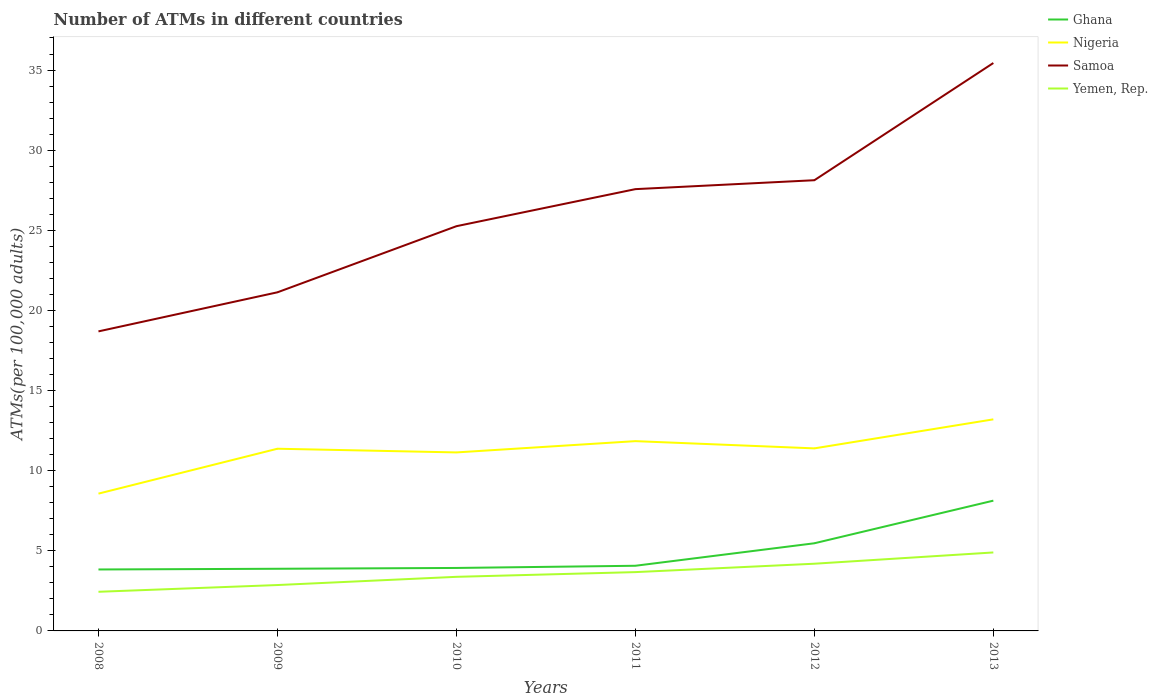Does the line corresponding to Yemen, Rep. intersect with the line corresponding to Nigeria?
Your answer should be very brief. No. Across all years, what is the maximum number of ATMs in Samoa?
Provide a short and direct response. 18.69. What is the total number of ATMs in Ghana in the graph?
Provide a succinct answer. -1.4. What is the difference between the highest and the second highest number of ATMs in Samoa?
Keep it short and to the point. 16.75. What is the difference between the highest and the lowest number of ATMs in Nigeria?
Your answer should be very brief. 4. How many lines are there?
Your response must be concise. 4. What is the difference between two consecutive major ticks on the Y-axis?
Make the answer very short. 5. Are the values on the major ticks of Y-axis written in scientific E-notation?
Make the answer very short. No. Does the graph contain grids?
Offer a terse response. No. Where does the legend appear in the graph?
Your answer should be very brief. Top right. How many legend labels are there?
Keep it short and to the point. 4. How are the legend labels stacked?
Your answer should be very brief. Vertical. What is the title of the graph?
Your response must be concise. Number of ATMs in different countries. Does "Slovak Republic" appear as one of the legend labels in the graph?
Offer a very short reply. No. What is the label or title of the Y-axis?
Your answer should be very brief. ATMs(per 100,0 adults). What is the ATMs(per 100,000 adults) of Ghana in 2008?
Keep it short and to the point. 3.84. What is the ATMs(per 100,000 adults) of Nigeria in 2008?
Your answer should be compact. 8.57. What is the ATMs(per 100,000 adults) of Samoa in 2008?
Your answer should be compact. 18.69. What is the ATMs(per 100,000 adults) of Yemen, Rep. in 2008?
Offer a terse response. 2.44. What is the ATMs(per 100,000 adults) of Ghana in 2009?
Provide a short and direct response. 3.88. What is the ATMs(per 100,000 adults) in Nigeria in 2009?
Your answer should be compact. 11.37. What is the ATMs(per 100,000 adults) of Samoa in 2009?
Offer a very short reply. 21.13. What is the ATMs(per 100,000 adults) of Yemen, Rep. in 2009?
Make the answer very short. 2.86. What is the ATMs(per 100,000 adults) in Ghana in 2010?
Give a very brief answer. 3.93. What is the ATMs(per 100,000 adults) of Nigeria in 2010?
Offer a terse response. 11.14. What is the ATMs(per 100,000 adults) of Samoa in 2010?
Provide a short and direct response. 25.26. What is the ATMs(per 100,000 adults) of Yemen, Rep. in 2010?
Provide a short and direct response. 3.38. What is the ATMs(per 100,000 adults) of Ghana in 2011?
Your response must be concise. 4.07. What is the ATMs(per 100,000 adults) of Nigeria in 2011?
Make the answer very short. 11.84. What is the ATMs(per 100,000 adults) of Samoa in 2011?
Keep it short and to the point. 27.57. What is the ATMs(per 100,000 adults) in Yemen, Rep. in 2011?
Provide a succinct answer. 3.67. What is the ATMs(per 100,000 adults) of Ghana in 2012?
Keep it short and to the point. 5.47. What is the ATMs(per 100,000 adults) of Nigeria in 2012?
Provide a succinct answer. 11.39. What is the ATMs(per 100,000 adults) in Samoa in 2012?
Provide a succinct answer. 28.12. What is the ATMs(per 100,000 adults) in Yemen, Rep. in 2012?
Your answer should be very brief. 4.19. What is the ATMs(per 100,000 adults) in Ghana in 2013?
Your answer should be very brief. 8.13. What is the ATMs(per 100,000 adults) in Nigeria in 2013?
Your answer should be very brief. 13.2. What is the ATMs(per 100,000 adults) in Samoa in 2013?
Offer a terse response. 35.44. What is the ATMs(per 100,000 adults) of Yemen, Rep. in 2013?
Make the answer very short. 4.9. Across all years, what is the maximum ATMs(per 100,000 adults) in Ghana?
Keep it short and to the point. 8.13. Across all years, what is the maximum ATMs(per 100,000 adults) in Nigeria?
Give a very brief answer. 13.2. Across all years, what is the maximum ATMs(per 100,000 adults) of Samoa?
Provide a short and direct response. 35.44. Across all years, what is the maximum ATMs(per 100,000 adults) of Yemen, Rep.?
Offer a terse response. 4.9. Across all years, what is the minimum ATMs(per 100,000 adults) in Ghana?
Offer a very short reply. 3.84. Across all years, what is the minimum ATMs(per 100,000 adults) of Nigeria?
Your response must be concise. 8.57. Across all years, what is the minimum ATMs(per 100,000 adults) of Samoa?
Your response must be concise. 18.69. Across all years, what is the minimum ATMs(per 100,000 adults) of Yemen, Rep.?
Your answer should be very brief. 2.44. What is the total ATMs(per 100,000 adults) in Ghana in the graph?
Provide a short and direct response. 29.31. What is the total ATMs(per 100,000 adults) of Nigeria in the graph?
Offer a very short reply. 67.51. What is the total ATMs(per 100,000 adults) in Samoa in the graph?
Make the answer very short. 156.21. What is the total ATMs(per 100,000 adults) of Yemen, Rep. in the graph?
Offer a very short reply. 21.44. What is the difference between the ATMs(per 100,000 adults) of Ghana in 2008 and that in 2009?
Offer a very short reply. -0.04. What is the difference between the ATMs(per 100,000 adults) in Nigeria in 2008 and that in 2009?
Keep it short and to the point. -2.8. What is the difference between the ATMs(per 100,000 adults) of Samoa in 2008 and that in 2009?
Give a very brief answer. -2.44. What is the difference between the ATMs(per 100,000 adults) of Yemen, Rep. in 2008 and that in 2009?
Your answer should be very brief. -0.42. What is the difference between the ATMs(per 100,000 adults) of Ghana in 2008 and that in 2010?
Your response must be concise. -0.09. What is the difference between the ATMs(per 100,000 adults) in Nigeria in 2008 and that in 2010?
Offer a terse response. -2.57. What is the difference between the ATMs(per 100,000 adults) in Samoa in 2008 and that in 2010?
Your answer should be compact. -6.56. What is the difference between the ATMs(per 100,000 adults) in Yemen, Rep. in 2008 and that in 2010?
Keep it short and to the point. -0.93. What is the difference between the ATMs(per 100,000 adults) of Ghana in 2008 and that in 2011?
Provide a short and direct response. -0.23. What is the difference between the ATMs(per 100,000 adults) of Nigeria in 2008 and that in 2011?
Provide a short and direct response. -3.28. What is the difference between the ATMs(per 100,000 adults) of Samoa in 2008 and that in 2011?
Offer a terse response. -8.88. What is the difference between the ATMs(per 100,000 adults) in Yemen, Rep. in 2008 and that in 2011?
Give a very brief answer. -1.23. What is the difference between the ATMs(per 100,000 adults) in Ghana in 2008 and that in 2012?
Offer a very short reply. -1.63. What is the difference between the ATMs(per 100,000 adults) of Nigeria in 2008 and that in 2012?
Offer a terse response. -2.82. What is the difference between the ATMs(per 100,000 adults) of Samoa in 2008 and that in 2012?
Your answer should be compact. -9.43. What is the difference between the ATMs(per 100,000 adults) in Yemen, Rep. in 2008 and that in 2012?
Your response must be concise. -1.75. What is the difference between the ATMs(per 100,000 adults) of Ghana in 2008 and that in 2013?
Ensure brevity in your answer.  -4.29. What is the difference between the ATMs(per 100,000 adults) of Nigeria in 2008 and that in 2013?
Provide a short and direct response. -4.64. What is the difference between the ATMs(per 100,000 adults) of Samoa in 2008 and that in 2013?
Make the answer very short. -16.75. What is the difference between the ATMs(per 100,000 adults) of Yemen, Rep. in 2008 and that in 2013?
Make the answer very short. -2.45. What is the difference between the ATMs(per 100,000 adults) of Ghana in 2009 and that in 2010?
Your answer should be very brief. -0.05. What is the difference between the ATMs(per 100,000 adults) in Nigeria in 2009 and that in 2010?
Your answer should be very brief. 0.23. What is the difference between the ATMs(per 100,000 adults) in Samoa in 2009 and that in 2010?
Your answer should be compact. -4.13. What is the difference between the ATMs(per 100,000 adults) of Yemen, Rep. in 2009 and that in 2010?
Provide a succinct answer. -0.51. What is the difference between the ATMs(per 100,000 adults) in Ghana in 2009 and that in 2011?
Provide a succinct answer. -0.19. What is the difference between the ATMs(per 100,000 adults) in Nigeria in 2009 and that in 2011?
Your answer should be very brief. -0.47. What is the difference between the ATMs(per 100,000 adults) of Samoa in 2009 and that in 2011?
Your answer should be very brief. -6.44. What is the difference between the ATMs(per 100,000 adults) in Yemen, Rep. in 2009 and that in 2011?
Your answer should be compact. -0.81. What is the difference between the ATMs(per 100,000 adults) of Ghana in 2009 and that in 2012?
Offer a very short reply. -1.59. What is the difference between the ATMs(per 100,000 adults) in Nigeria in 2009 and that in 2012?
Provide a short and direct response. -0.02. What is the difference between the ATMs(per 100,000 adults) of Samoa in 2009 and that in 2012?
Provide a succinct answer. -6.99. What is the difference between the ATMs(per 100,000 adults) of Yemen, Rep. in 2009 and that in 2012?
Provide a succinct answer. -1.33. What is the difference between the ATMs(per 100,000 adults) of Ghana in 2009 and that in 2013?
Provide a succinct answer. -4.25. What is the difference between the ATMs(per 100,000 adults) of Nigeria in 2009 and that in 2013?
Your response must be concise. -1.83. What is the difference between the ATMs(per 100,000 adults) of Samoa in 2009 and that in 2013?
Ensure brevity in your answer.  -14.31. What is the difference between the ATMs(per 100,000 adults) of Yemen, Rep. in 2009 and that in 2013?
Your answer should be compact. -2.03. What is the difference between the ATMs(per 100,000 adults) in Ghana in 2010 and that in 2011?
Provide a short and direct response. -0.14. What is the difference between the ATMs(per 100,000 adults) of Nigeria in 2010 and that in 2011?
Your response must be concise. -0.7. What is the difference between the ATMs(per 100,000 adults) in Samoa in 2010 and that in 2011?
Offer a terse response. -2.31. What is the difference between the ATMs(per 100,000 adults) in Yemen, Rep. in 2010 and that in 2011?
Provide a succinct answer. -0.29. What is the difference between the ATMs(per 100,000 adults) of Ghana in 2010 and that in 2012?
Your response must be concise. -1.54. What is the difference between the ATMs(per 100,000 adults) of Nigeria in 2010 and that in 2012?
Make the answer very short. -0.25. What is the difference between the ATMs(per 100,000 adults) of Samoa in 2010 and that in 2012?
Keep it short and to the point. -2.87. What is the difference between the ATMs(per 100,000 adults) of Yemen, Rep. in 2010 and that in 2012?
Ensure brevity in your answer.  -0.82. What is the difference between the ATMs(per 100,000 adults) of Ghana in 2010 and that in 2013?
Keep it short and to the point. -4.2. What is the difference between the ATMs(per 100,000 adults) of Nigeria in 2010 and that in 2013?
Give a very brief answer. -2.06. What is the difference between the ATMs(per 100,000 adults) of Samoa in 2010 and that in 2013?
Keep it short and to the point. -10.18. What is the difference between the ATMs(per 100,000 adults) in Yemen, Rep. in 2010 and that in 2013?
Offer a terse response. -1.52. What is the difference between the ATMs(per 100,000 adults) of Ghana in 2011 and that in 2012?
Offer a terse response. -1.4. What is the difference between the ATMs(per 100,000 adults) in Nigeria in 2011 and that in 2012?
Offer a terse response. 0.45. What is the difference between the ATMs(per 100,000 adults) in Samoa in 2011 and that in 2012?
Provide a succinct answer. -0.56. What is the difference between the ATMs(per 100,000 adults) of Yemen, Rep. in 2011 and that in 2012?
Provide a short and direct response. -0.52. What is the difference between the ATMs(per 100,000 adults) in Ghana in 2011 and that in 2013?
Offer a very short reply. -4.06. What is the difference between the ATMs(per 100,000 adults) in Nigeria in 2011 and that in 2013?
Give a very brief answer. -1.36. What is the difference between the ATMs(per 100,000 adults) in Samoa in 2011 and that in 2013?
Your response must be concise. -7.87. What is the difference between the ATMs(per 100,000 adults) in Yemen, Rep. in 2011 and that in 2013?
Keep it short and to the point. -1.23. What is the difference between the ATMs(per 100,000 adults) in Ghana in 2012 and that in 2013?
Ensure brevity in your answer.  -2.66. What is the difference between the ATMs(per 100,000 adults) in Nigeria in 2012 and that in 2013?
Your answer should be compact. -1.81. What is the difference between the ATMs(per 100,000 adults) of Samoa in 2012 and that in 2013?
Give a very brief answer. -7.31. What is the difference between the ATMs(per 100,000 adults) of Yemen, Rep. in 2012 and that in 2013?
Your response must be concise. -0.7. What is the difference between the ATMs(per 100,000 adults) in Ghana in 2008 and the ATMs(per 100,000 adults) in Nigeria in 2009?
Keep it short and to the point. -7.53. What is the difference between the ATMs(per 100,000 adults) of Ghana in 2008 and the ATMs(per 100,000 adults) of Samoa in 2009?
Make the answer very short. -17.3. What is the difference between the ATMs(per 100,000 adults) of Ghana in 2008 and the ATMs(per 100,000 adults) of Yemen, Rep. in 2009?
Offer a very short reply. 0.97. What is the difference between the ATMs(per 100,000 adults) of Nigeria in 2008 and the ATMs(per 100,000 adults) of Samoa in 2009?
Offer a terse response. -12.56. What is the difference between the ATMs(per 100,000 adults) in Nigeria in 2008 and the ATMs(per 100,000 adults) in Yemen, Rep. in 2009?
Keep it short and to the point. 5.7. What is the difference between the ATMs(per 100,000 adults) in Samoa in 2008 and the ATMs(per 100,000 adults) in Yemen, Rep. in 2009?
Your response must be concise. 15.83. What is the difference between the ATMs(per 100,000 adults) of Ghana in 2008 and the ATMs(per 100,000 adults) of Nigeria in 2010?
Your response must be concise. -7.3. What is the difference between the ATMs(per 100,000 adults) of Ghana in 2008 and the ATMs(per 100,000 adults) of Samoa in 2010?
Your response must be concise. -21.42. What is the difference between the ATMs(per 100,000 adults) in Ghana in 2008 and the ATMs(per 100,000 adults) in Yemen, Rep. in 2010?
Provide a succinct answer. 0.46. What is the difference between the ATMs(per 100,000 adults) of Nigeria in 2008 and the ATMs(per 100,000 adults) of Samoa in 2010?
Your answer should be compact. -16.69. What is the difference between the ATMs(per 100,000 adults) in Nigeria in 2008 and the ATMs(per 100,000 adults) in Yemen, Rep. in 2010?
Give a very brief answer. 5.19. What is the difference between the ATMs(per 100,000 adults) in Samoa in 2008 and the ATMs(per 100,000 adults) in Yemen, Rep. in 2010?
Offer a terse response. 15.32. What is the difference between the ATMs(per 100,000 adults) in Ghana in 2008 and the ATMs(per 100,000 adults) in Nigeria in 2011?
Your response must be concise. -8.01. What is the difference between the ATMs(per 100,000 adults) of Ghana in 2008 and the ATMs(per 100,000 adults) of Samoa in 2011?
Give a very brief answer. -23.73. What is the difference between the ATMs(per 100,000 adults) of Ghana in 2008 and the ATMs(per 100,000 adults) of Yemen, Rep. in 2011?
Your response must be concise. 0.16. What is the difference between the ATMs(per 100,000 adults) in Nigeria in 2008 and the ATMs(per 100,000 adults) in Samoa in 2011?
Provide a succinct answer. -19. What is the difference between the ATMs(per 100,000 adults) in Nigeria in 2008 and the ATMs(per 100,000 adults) in Yemen, Rep. in 2011?
Your answer should be very brief. 4.9. What is the difference between the ATMs(per 100,000 adults) in Samoa in 2008 and the ATMs(per 100,000 adults) in Yemen, Rep. in 2011?
Your response must be concise. 15.02. What is the difference between the ATMs(per 100,000 adults) of Ghana in 2008 and the ATMs(per 100,000 adults) of Nigeria in 2012?
Ensure brevity in your answer.  -7.56. What is the difference between the ATMs(per 100,000 adults) in Ghana in 2008 and the ATMs(per 100,000 adults) in Samoa in 2012?
Provide a succinct answer. -24.29. What is the difference between the ATMs(per 100,000 adults) of Ghana in 2008 and the ATMs(per 100,000 adults) of Yemen, Rep. in 2012?
Ensure brevity in your answer.  -0.36. What is the difference between the ATMs(per 100,000 adults) in Nigeria in 2008 and the ATMs(per 100,000 adults) in Samoa in 2012?
Ensure brevity in your answer.  -19.56. What is the difference between the ATMs(per 100,000 adults) in Nigeria in 2008 and the ATMs(per 100,000 adults) in Yemen, Rep. in 2012?
Give a very brief answer. 4.37. What is the difference between the ATMs(per 100,000 adults) in Samoa in 2008 and the ATMs(per 100,000 adults) in Yemen, Rep. in 2012?
Keep it short and to the point. 14.5. What is the difference between the ATMs(per 100,000 adults) of Ghana in 2008 and the ATMs(per 100,000 adults) of Nigeria in 2013?
Offer a terse response. -9.37. What is the difference between the ATMs(per 100,000 adults) in Ghana in 2008 and the ATMs(per 100,000 adults) in Samoa in 2013?
Ensure brevity in your answer.  -31.6. What is the difference between the ATMs(per 100,000 adults) in Ghana in 2008 and the ATMs(per 100,000 adults) in Yemen, Rep. in 2013?
Offer a very short reply. -1.06. What is the difference between the ATMs(per 100,000 adults) of Nigeria in 2008 and the ATMs(per 100,000 adults) of Samoa in 2013?
Your response must be concise. -26.87. What is the difference between the ATMs(per 100,000 adults) in Nigeria in 2008 and the ATMs(per 100,000 adults) in Yemen, Rep. in 2013?
Provide a short and direct response. 3.67. What is the difference between the ATMs(per 100,000 adults) of Samoa in 2008 and the ATMs(per 100,000 adults) of Yemen, Rep. in 2013?
Your response must be concise. 13.79. What is the difference between the ATMs(per 100,000 adults) of Ghana in 2009 and the ATMs(per 100,000 adults) of Nigeria in 2010?
Provide a short and direct response. -7.26. What is the difference between the ATMs(per 100,000 adults) in Ghana in 2009 and the ATMs(per 100,000 adults) in Samoa in 2010?
Offer a very short reply. -21.38. What is the difference between the ATMs(per 100,000 adults) of Ghana in 2009 and the ATMs(per 100,000 adults) of Yemen, Rep. in 2010?
Offer a terse response. 0.5. What is the difference between the ATMs(per 100,000 adults) of Nigeria in 2009 and the ATMs(per 100,000 adults) of Samoa in 2010?
Your answer should be compact. -13.89. What is the difference between the ATMs(per 100,000 adults) in Nigeria in 2009 and the ATMs(per 100,000 adults) in Yemen, Rep. in 2010?
Ensure brevity in your answer.  7.99. What is the difference between the ATMs(per 100,000 adults) of Samoa in 2009 and the ATMs(per 100,000 adults) of Yemen, Rep. in 2010?
Make the answer very short. 17.75. What is the difference between the ATMs(per 100,000 adults) in Ghana in 2009 and the ATMs(per 100,000 adults) in Nigeria in 2011?
Your answer should be very brief. -7.96. What is the difference between the ATMs(per 100,000 adults) of Ghana in 2009 and the ATMs(per 100,000 adults) of Samoa in 2011?
Keep it short and to the point. -23.69. What is the difference between the ATMs(per 100,000 adults) of Ghana in 2009 and the ATMs(per 100,000 adults) of Yemen, Rep. in 2011?
Offer a terse response. 0.21. What is the difference between the ATMs(per 100,000 adults) in Nigeria in 2009 and the ATMs(per 100,000 adults) in Samoa in 2011?
Your answer should be compact. -16.2. What is the difference between the ATMs(per 100,000 adults) in Nigeria in 2009 and the ATMs(per 100,000 adults) in Yemen, Rep. in 2011?
Provide a short and direct response. 7.7. What is the difference between the ATMs(per 100,000 adults) in Samoa in 2009 and the ATMs(per 100,000 adults) in Yemen, Rep. in 2011?
Give a very brief answer. 17.46. What is the difference between the ATMs(per 100,000 adults) in Ghana in 2009 and the ATMs(per 100,000 adults) in Nigeria in 2012?
Keep it short and to the point. -7.51. What is the difference between the ATMs(per 100,000 adults) in Ghana in 2009 and the ATMs(per 100,000 adults) in Samoa in 2012?
Keep it short and to the point. -24.25. What is the difference between the ATMs(per 100,000 adults) of Ghana in 2009 and the ATMs(per 100,000 adults) of Yemen, Rep. in 2012?
Keep it short and to the point. -0.31. What is the difference between the ATMs(per 100,000 adults) of Nigeria in 2009 and the ATMs(per 100,000 adults) of Samoa in 2012?
Offer a very short reply. -16.76. What is the difference between the ATMs(per 100,000 adults) of Nigeria in 2009 and the ATMs(per 100,000 adults) of Yemen, Rep. in 2012?
Ensure brevity in your answer.  7.18. What is the difference between the ATMs(per 100,000 adults) in Samoa in 2009 and the ATMs(per 100,000 adults) in Yemen, Rep. in 2012?
Provide a short and direct response. 16.94. What is the difference between the ATMs(per 100,000 adults) in Ghana in 2009 and the ATMs(per 100,000 adults) in Nigeria in 2013?
Provide a short and direct response. -9.32. What is the difference between the ATMs(per 100,000 adults) of Ghana in 2009 and the ATMs(per 100,000 adults) of Samoa in 2013?
Your answer should be compact. -31.56. What is the difference between the ATMs(per 100,000 adults) in Ghana in 2009 and the ATMs(per 100,000 adults) in Yemen, Rep. in 2013?
Provide a short and direct response. -1.02. What is the difference between the ATMs(per 100,000 adults) of Nigeria in 2009 and the ATMs(per 100,000 adults) of Samoa in 2013?
Give a very brief answer. -24.07. What is the difference between the ATMs(per 100,000 adults) in Nigeria in 2009 and the ATMs(per 100,000 adults) in Yemen, Rep. in 2013?
Provide a succinct answer. 6.47. What is the difference between the ATMs(per 100,000 adults) of Samoa in 2009 and the ATMs(per 100,000 adults) of Yemen, Rep. in 2013?
Make the answer very short. 16.23. What is the difference between the ATMs(per 100,000 adults) of Ghana in 2010 and the ATMs(per 100,000 adults) of Nigeria in 2011?
Your response must be concise. -7.91. What is the difference between the ATMs(per 100,000 adults) of Ghana in 2010 and the ATMs(per 100,000 adults) of Samoa in 2011?
Provide a short and direct response. -23.64. What is the difference between the ATMs(per 100,000 adults) of Ghana in 2010 and the ATMs(per 100,000 adults) of Yemen, Rep. in 2011?
Make the answer very short. 0.26. What is the difference between the ATMs(per 100,000 adults) in Nigeria in 2010 and the ATMs(per 100,000 adults) in Samoa in 2011?
Make the answer very short. -16.43. What is the difference between the ATMs(per 100,000 adults) of Nigeria in 2010 and the ATMs(per 100,000 adults) of Yemen, Rep. in 2011?
Make the answer very short. 7.47. What is the difference between the ATMs(per 100,000 adults) of Samoa in 2010 and the ATMs(per 100,000 adults) of Yemen, Rep. in 2011?
Make the answer very short. 21.59. What is the difference between the ATMs(per 100,000 adults) in Ghana in 2010 and the ATMs(per 100,000 adults) in Nigeria in 2012?
Give a very brief answer. -7.46. What is the difference between the ATMs(per 100,000 adults) in Ghana in 2010 and the ATMs(per 100,000 adults) in Samoa in 2012?
Offer a very short reply. -24.19. What is the difference between the ATMs(per 100,000 adults) in Ghana in 2010 and the ATMs(per 100,000 adults) in Yemen, Rep. in 2012?
Make the answer very short. -0.26. What is the difference between the ATMs(per 100,000 adults) in Nigeria in 2010 and the ATMs(per 100,000 adults) in Samoa in 2012?
Provide a short and direct response. -16.99. What is the difference between the ATMs(per 100,000 adults) of Nigeria in 2010 and the ATMs(per 100,000 adults) of Yemen, Rep. in 2012?
Keep it short and to the point. 6.95. What is the difference between the ATMs(per 100,000 adults) of Samoa in 2010 and the ATMs(per 100,000 adults) of Yemen, Rep. in 2012?
Offer a terse response. 21.06. What is the difference between the ATMs(per 100,000 adults) of Ghana in 2010 and the ATMs(per 100,000 adults) of Nigeria in 2013?
Provide a succinct answer. -9.27. What is the difference between the ATMs(per 100,000 adults) in Ghana in 2010 and the ATMs(per 100,000 adults) in Samoa in 2013?
Give a very brief answer. -31.51. What is the difference between the ATMs(per 100,000 adults) in Ghana in 2010 and the ATMs(per 100,000 adults) in Yemen, Rep. in 2013?
Provide a succinct answer. -0.97. What is the difference between the ATMs(per 100,000 adults) in Nigeria in 2010 and the ATMs(per 100,000 adults) in Samoa in 2013?
Offer a terse response. -24.3. What is the difference between the ATMs(per 100,000 adults) in Nigeria in 2010 and the ATMs(per 100,000 adults) in Yemen, Rep. in 2013?
Your answer should be compact. 6.24. What is the difference between the ATMs(per 100,000 adults) of Samoa in 2010 and the ATMs(per 100,000 adults) of Yemen, Rep. in 2013?
Offer a terse response. 20.36. What is the difference between the ATMs(per 100,000 adults) in Ghana in 2011 and the ATMs(per 100,000 adults) in Nigeria in 2012?
Provide a succinct answer. -7.32. What is the difference between the ATMs(per 100,000 adults) of Ghana in 2011 and the ATMs(per 100,000 adults) of Samoa in 2012?
Your answer should be very brief. -24.06. What is the difference between the ATMs(per 100,000 adults) in Ghana in 2011 and the ATMs(per 100,000 adults) in Yemen, Rep. in 2012?
Your response must be concise. -0.13. What is the difference between the ATMs(per 100,000 adults) in Nigeria in 2011 and the ATMs(per 100,000 adults) in Samoa in 2012?
Offer a very short reply. -16.28. What is the difference between the ATMs(per 100,000 adults) of Nigeria in 2011 and the ATMs(per 100,000 adults) of Yemen, Rep. in 2012?
Keep it short and to the point. 7.65. What is the difference between the ATMs(per 100,000 adults) of Samoa in 2011 and the ATMs(per 100,000 adults) of Yemen, Rep. in 2012?
Make the answer very short. 23.37. What is the difference between the ATMs(per 100,000 adults) of Ghana in 2011 and the ATMs(per 100,000 adults) of Nigeria in 2013?
Provide a succinct answer. -9.14. What is the difference between the ATMs(per 100,000 adults) in Ghana in 2011 and the ATMs(per 100,000 adults) in Samoa in 2013?
Your answer should be compact. -31.37. What is the difference between the ATMs(per 100,000 adults) in Ghana in 2011 and the ATMs(per 100,000 adults) in Yemen, Rep. in 2013?
Your response must be concise. -0.83. What is the difference between the ATMs(per 100,000 adults) in Nigeria in 2011 and the ATMs(per 100,000 adults) in Samoa in 2013?
Your answer should be compact. -23.6. What is the difference between the ATMs(per 100,000 adults) in Nigeria in 2011 and the ATMs(per 100,000 adults) in Yemen, Rep. in 2013?
Make the answer very short. 6.95. What is the difference between the ATMs(per 100,000 adults) in Samoa in 2011 and the ATMs(per 100,000 adults) in Yemen, Rep. in 2013?
Your answer should be very brief. 22.67. What is the difference between the ATMs(per 100,000 adults) of Ghana in 2012 and the ATMs(per 100,000 adults) of Nigeria in 2013?
Your response must be concise. -7.73. What is the difference between the ATMs(per 100,000 adults) in Ghana in 2012 and the ATMs(per 100,000 adults) in Samoa in 2013?
Offer a very short reply. -29.97. What is the difference between the ATMs(per 100,000 adults) of Ghana in 2012 and the ATMs(per 100,000 adults) of Yemen, Rep. in 2013?
Offer a terse response. 0.57. What is the difference between the ATMs(per 100,000 adults) of Nigeria in 2012 and the ATMs(per 100,000 adults) of Samoa in 2013?
Your answer should be compact. -24.05. What is the difference between the ATMs(per 100,000 adults) of Nigeria in 2012 and the ATMs(per 100,000 adults) of Yemen, Rep. in 2013?
Your answer should be very brief. 6.49. What is the difference between the ATMs(per 100,000 adults) of Samoa in 2012 and the ATMs(per 100,000 adults) of Yemen, Rep. in 2013?
Provide a succinct answer. 23.23. What is the average ATMs(per 100,000 adults) in Ghana per year?
Ensure brevity in your answer.  4.88. What is the average ATMs(per 100,000 adults) of Nigeria per year?
Ensure brevity in your answer.  11.25. What is the average ATMs(per 100,000 adults) in Samoa per year?
Give a very brief answer. 26.03. What is the average ATMs(per 100,000 adults) of Yemen, Rep. per year?
Offer a very short reply. 3.57. In the year 2008, what is the difference between the ATMs(per 100,000 adults) of Ghana and ATMs(per 100,000 adults) of Nigeria?
Your answer should be compact. -4.73. In the year 2008, what is the difference between the ATMs(per 100,000 adults) in Ghana and ATMs(per 100,000 adults) in Samoa?
Your response must be concise. -14.86. In the year 2008, what is the difference between the ATMs(per 100,000 adults) in Ghana and ATMs(per 100,000 adults) in Yemen, Rep.?
Your response must be concise. 1.39. In the year 2008, what is the difference between the ATMs(per 100,000 adults) of Nigeria and ATMs(per 100,000 adults) of Samoa?
Give a very brief answer. -10.12. In the year 2008, what is the difference between the ATMs(per 100,000 adults) of Nigeria and ATMs(per 100,000 adults) of Yemen, Rep.?
Provide a succinct answer. 6.12. In the year 2008, what is the difference between the ATMs(per 100,000 adults) in Samoa and ATMs(per 100,000 adults) in Yemen, Rep.?
Make the answer very short. 16.25. In the year 2009, what is the difference between the ATMs(per 100,000 adults) of Ghana and ATMs(per 100,000 adults) of Nigeria?
Ensure brevity in your answer.  -7.49. In the year 2009, what is the difference between the ATMs(per 100,000 adults) of Ghana and ATMs(per 100,000 adults) of Samoa?
Provide a succinct answer. -17.25. In the year 2009, what is the difference between the ATMs(per 100,000 adults) in Ghana and ATMs(per 100,000 adults) in Yemen, Rep.?
Your answer should be compact. 1.02. In the year 2009, what is the difference between the ATMs(per 100,000 adults) of Nigeria and ATMs(per 100,000 adults) of Samoa?
Offer a very short reply. -9.76. In the year 2009, what is the difference between the ATMs(per 100,000 adults) in Nigeria and ATMs(per 100,000 adults) in Yemen, Rep.?
Offer a very short reply. 8.51. In the year 2009, what is the difference between the ATMs(per 100,000 adults) of Samoa and ATMs(per 100,000 adults) of Yemen, Rep.?
Provide a succinct answer. 18.27. In the year 2010, what is the difference between the ATMs(per 100,000 adults) of Ghana and ATMs(per 100,000 adults) of Nigeria?
Your response must be concise. -7.21. In the year 2010, what is the difference between the ATMs(per 100,000 adults) of Ghana and ATMs(per 100,000 adults) of Samoa?
Provide a short and direct response. -21.33. In the year 2010, what is the difference between the ATMs(per 100,000 adults) in Ghana and ATMs(per 100,000 adults) in Yemen, Rep.?
Your answer should be very brief. 0.55. In the year 2010, what is the difference between the ATMs(per 100,000 adults) of Nigeria and ATMs(per 100,000 adults) of Samoa?
Provide a succinct answer. -14.12. In the year 2010, what is the difference between the ATMs(per 100,000 adults) of Nigeria and ATMs(per 100,000 adults) of Yemen, Rep.?
Provide a short and direct response. 7.76. In the year 2010, what is the difference between the ATMs(per 100,000 adults) in Samoa and ATMs(per 100,000 adults) in Yemen, Rep.?
Your answer should be very brief. 21.88. In the year 2011, what is the difference between the ATMs(per 100,000 adults) in Ghana and ATMs(per 100,000 adults) in Nigeria?
Ensure brevity in your answer.  -7.78. In the year 2011, what is the difference between the ATMs(per 100,000 adults) of Ghana and ATMs(per 100,000 adults) of Samoa?
Provide a short and direct response. -23.5. In the year 2011, what is the difference between the ATMs(per 100,000 adults) in Ghana and ATMs(per 100,000 adults) in Yemen, Rep.?
Your answer should be very brief. 0.4. In the year 2011, what is the difference between the ATMs(per 100,000 adults) in Nigeria and ATMs(per 100,000 adults) in Samoa?
Your answer should be very brief. -15.73. In the year 2011, what is the difference between the ATMs(per 100,000 adults) of Nigeria and ATMs(per 100,000 adults) of Yemen, Rep.?
Keep it short and to the point. 8.17. In the year 2011, what is the difference between the ATMs(per 100,000 adults) of Samoa and ATMs(per 100,000 adults) of Yemen, Rep.?
Provide a succinct answer. 23.9. In the year 2012, what is the difference between the ATMs(per 100,000 adults) in Ghana and ATMs(per 100,000 adults) in Nigeria?
Provide a short and direct response. -5.92. In the year 2012, what is the difference between the ATMs(per 100,000 adults) of Ghana and ATMs(per 100,000 adults) of Samoa?
Keep it short and to the point. -22.65. In the year 2012, what is the difference between the ATMs(per 100,000 adults) of Ghana and ATMs(per 100,000 adults) of Yemen, Rep.?
Your response must be concise. 1.28. In the year 2012, what is the difference between the ATMs(per 100,000 adults) in Nigeria and ATMs(per 100,000 adults) in Samoa?
Provide a succinct answer. -16.73. In the year 2012, what is the difference between the ATMs(per 100,000 adults) in Nigeria and ATMs(per 100,000 adults) in Yemen, Rep.?
Your response must be concise. 7.2. In the year 2012, what is the difference between the ATMs(per 100,000 adults) of Samoa and ATMs(per 100,000 adults) of Yemen, Rep.?
Provide a succinct answer. 23.93. In the year 2013, what is the difference between the ATMs(per 100,000 adults) in Ghana and ATMs(per 100,000 adults) in Nigeria?
Ensure brevity in your answer.  -5.07. In the year 2013, what is the difference between the ATMs(per 100,000 adults) of Ghana and ATMs(per 100,000 adults) of Samoa?
Offer a terse response. -27.31. In the year 2013, what is the difference between the ATMs(per 100,000 adults) of Ghana and ATMs(per 100,000 adults) of Yemen, Rep.?
Keep it short and to the point. 3.23. In the year 2013, what is the difference between the ATMs(per 100,000 adults) of Nigeria and ATMs(per 100,000 adults) of Samoa?
Your response must be concise. -22.24. In the year 2013, what is the difference between the ATMs(per 100,000 adults) of Nigeria and ATMs(per 100,000 adults) of Yemen, Rep.?
Offer a very short reply. 8.31. In the year 2013, what is the difference between the ATMs(per 100,000 adults) in Samoa and ATMs(per 100,000 adults) in Yemen, Rep.?
Provide a succinct answer. 30.54. What is the ratio of the ATMs(per 100,000 adults) of Ghana in 2008 to that in 2009?
Give a very brief answer. 0.99. What is the ratio of the ATMs(per 100,000 adults) in Nigeria in 2008 to that in 2009?
Your answer should be compact. 0.75. What is the ratio of the ATMs(per 100,000 adults) of Samoa in 2008 to that in 2009?
Offer a terse response. 0.88. What is the ratio of the ATMs(per 100,000 adults) of Yemen, Rep. in 2008 to that in 2009?
Your answer should be compact. 0.85. What is the ratio of the ATMs(per 100,000 adults) of Nigeria in 2008 to that in 2010?
Make the answer very short. 0.77. What is the ratio of the ATMs(per 100,000 adults) of Samoa in 2008 to that in 2010?
Your answer should be very brief. 0.74. What is the ratio of the ATMs(per 100,000 adults) in Yemen, Rep. in 2008 to that in 2010?
Offer a terse response. 0.72. What is the ratio of the ATMs(per 100,000 adults) in Ghana in 2008 to that in 2011?
Ensure brevity in your answer.  0.94. What is the ratio of the ATMs(per 100,000 adults) of Nigeria in 2008 to that in 2011?
Provide a short and direct response. 0.72. What is the ratio of the ATMs(per 100,000 adults) of Samoa in 2008 to that in 2011?
Your answer should be compact. 0.68. What is the ratio of the ATMs(per 100,000 adults) of Yemen, Rep. in 2008 to that in 2011?
Your response must be concise. 0.67. What is the ratio of the ATMs(per 100,000 adults) of Ghana in 2008 to that in 2012?
Offer a terse response. 0.7. What is the ratio of the ATMs(per 100,000 adults) of Nigeria in 2008 to that in 2012?
Your answer should be very brief. 0.75. What is the ratio of the ATMs(per 100,000 adults) in Samoa in 2008 to that in 2012?
Make the answer very short. 0.66. What is the ratio of the ATMs(per 100,000 adults) of Yemen, Rep. in 2008 to that in 2012?
Make the answer very short. 0.58. What is the ratio of the ATMs(per 100,000 adults) of Ghana in 2008 to that in 2013?
Offer a terse response. 0.47. What is the ratio of the ATMs(per 100,000 adults) in Nigeria in 2008 to that in 2013?
Your answer should be very brief. 0.65. What is the ratio of the ATMs(per 100,000 adults) in Samoa in 2008 to that in 2013?
Give a very brief answer. 0.53. What is the ratio of the ATMs(per 100,000 adults) of Yemen, Rep. in 2008 to that in 2013?
Keep it short and to the point. 0.5. What is the ratio of the ATMs(per 100,000 adults) in Ghana in 2009 to that in 2010?
Ensure brevity in your answer.  0.99. What is the ratio of the ATMs(per 100,000 adults) of Nigeria in 2009 to that in 2010?
Provide a succinct answer. 1.02. What is the ratio of the ATMs(per 100,000 adults) in Samoa in 2009 to that in 2010?
Provide a short and direct response. 0.84. What is the ratio of the ATMs(per 100,000 adults) of Yemen, Rep. in 2009 to that in 2010?
Give a very brief answer. 0.85. What is the ratio of the ATMs(per 100,000 adults) of Ghana in 2009 to that in 2011?
Keep it short and to the point. 0.95. What is the ratio of the ATMs(per 100,000 adults) in Samoa in 2009 to that in 2011?
Ensure brevity in your answer.  0.77. What is the ratio of the ATMs(per 100,000 adults) in Yemen, Rep. in 2009 to that in 2011?
Provide a succinct answer. 0.78. What is the ratio of the ATMs(per 100,000 adults) of Ghana in 2009 to that in 2012?
Provide a short and direct response. 0.71. What is the ratio of the ATMs(per 100,000 adults) in Nigeria in 2009 to that in 2012?
Provide a succinct answer. 1. What is the ratio of the ATMs(per 100,000 adults) of Samoa in 2009 to that in 2012?
Your answer should be very brief. 0.75. What is the ratio of the ATMs(per 100,000 adults) of Yemen, Rep. in 2009 to that in 2012?
Your answer should be compact. 0.68. What is the ratio of the ATMs(per 100,000 adults) of Ghana in 2009 to that in 2013?
Give a very brief answer. 0.48. What is the ratio of the ATMs(per 100,000 adults) of Nigeria in 2009 to that in 2013?
Offer a terse response. 0.86. What is the ratio of the ATMs(per 100,000 adults) in Samoa in 2009 to that in 2013?
Make the answer very short. 0.6. What is the ratio of the ATMs(per 100,000 adults) in Yemen, Rep. in 2009 to that in 2013?
Your answer should be very brief. 0.58. What is the ratio of the ATMs(per 100,000 adults) in Ghana in 2010 to that in 2011?
Provide a short and direct response. 0.97. What is the ratio of the ATMs(per 100,000 adults) of Nigeria in 2010 to that in 2011?
Your answer should be very brief. 0.94. What is the ratio of the ATMs(per 100,000 adults) of Samoa in 2010 to that in 2011?
Provide a succinct answer. 0.92. What is the ratio of the ATMs(per 100,000 adults) of Yemen, Rep. in 2010 to that in 2011?
Keep it short and to the point. 0.92. What is the ratio of the ATMs(per 100,000 adults) in Ghana in 2010 to that in 2012?
Make the answer very short. 0.72. What is the ratio of the ATMs(per 100,000 adults) in Nigeria in 2010 to that in 2012?
Your answer should be compact. 0.98. What is the ratio of the ATMs(per 100,000 adults) in Samoa in 2010 to that in 2012?
Your answer should be compact. 0.9. What is the ratio of the ATMs(per 100,000 adults) in Yemen, Rep. in 2010 to that in 2012?
Provide a succinct answer. 0.8. What is the ratio of the ATMs(per 100,000 adults) in Ghana in 2010 to that in 2013?
Your response must be concise. 0.48. What is the ratio of the ATMs(per 100,000 adults) in Nigeria in 2010 to that in 2013?
Provide a succinct answer. 0.84. What is the ratio of the ATMs(per 100,000 adults) in Samoa in 2010 to that in 2013?
Make the answer very short. 0.71. What is the ratio of the ATMs(per 100,000 adults) of Yemen, Rep. in 2010 to that in 2013?
Keep it short and to the point. 0.69. What is the ratio of the ATMs(per 100,000 adults) of Ghana in 2011 to that in 2012?
Provide a short and direct response. 0.74. What is the ratio of the ATMs(per 100,000 adults) of Nigeria in 2011 to that in 2012?
Provide a succinct answer. 1.04. What is the ratio of the ATMs(per 100,000 adults) of Samoa in 2011 to that in 2012?
Provide a succinct answer. 0.98. What is the ratio of the ATMs(per 100,000 adults) in Yemen, Rep. in 2011 to that in 2012?
Your answer should be very brief. 0.88. What is the ratio of the ATMs(per 100,000 adults) in Ghana in 2011 to that in 2013?
Your response must be concise. 0.5. What is the ratio of the ATMs(per 100,000 adults) of Nigeria in 2011 to that in 2013?
Make the answer very short. 0.9. What is the ratio of the ATMs(per 100,000 adults) of Samoa in 2011 to that in 2013?
Give a very brief answer. 0.78. What is the ratio of the ATMs(per 100,000 adults) in Yemen, Rep. in 2011 to that in 2013?
Offer a terse response. 0.75. What is the ratio of the ATMs(per 100,000 adults) in Ghana in 2012 to that in 2013?
Your answer should be very brief. 0.67. What is the ratio of the ATMs(per 100,000 adults) of Nigeria in 2012 to that in 2013?
Keep it short and to the point. 0.86. What is the ratio of the ATMs(per 100,000 adults) of Samoa in 2012 to that in 2013?
Give a very brief answer. 0.79. What is the ratio of the ATMs(per 100,000 adults) of Yemen, Rep. in 2012 to that in 2013?
Your answer should be compact. 0.86. What is the difference between the highest and the second highest ATMs(per 100,000 adults) of Ghana?
Provide a succinct answer. 2.66. What is the difference between the highest and the second highest ATMs(per 100,000 adults) in Nigeria?
Give a very brief answer. 1.36. What is the difference between the highest and the second highest ATMs(per 100,000 adults) in Samoa?
Your answer should be compact. 7.31. What is the difference between the highest and the second highest ATMs(per 100,000 adults) of Yemen, Rep.?
Provide a short and direct response. 0.7. What is the difference between the highest and the lowest ATMs(per 100,000 adults) of Ghana?
Make the answer very short. 4.29. What is the difference between the highest and the lowest ATMs(per 100,000 adults) of Nigeria?
Provide a succinct answer. 4.64. What is the difference between the highest and the lowest ATMs(per 100,000 adults) of Samoa?
Your answer should be compact. 16.75. What is the difference between the highest and the lowest ATMs(per 100,000 adults) in Yemen, Rep.?
Make the answer very short. 2.45. 